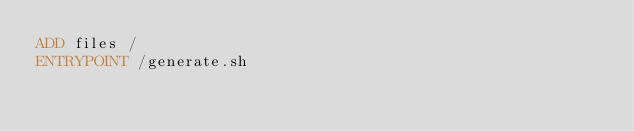<code> <loc_0><loc_0><loc_500><loc_500><_Dockerfile_>ADD files /
ENTRYPOINT /generate.sh
</code> 